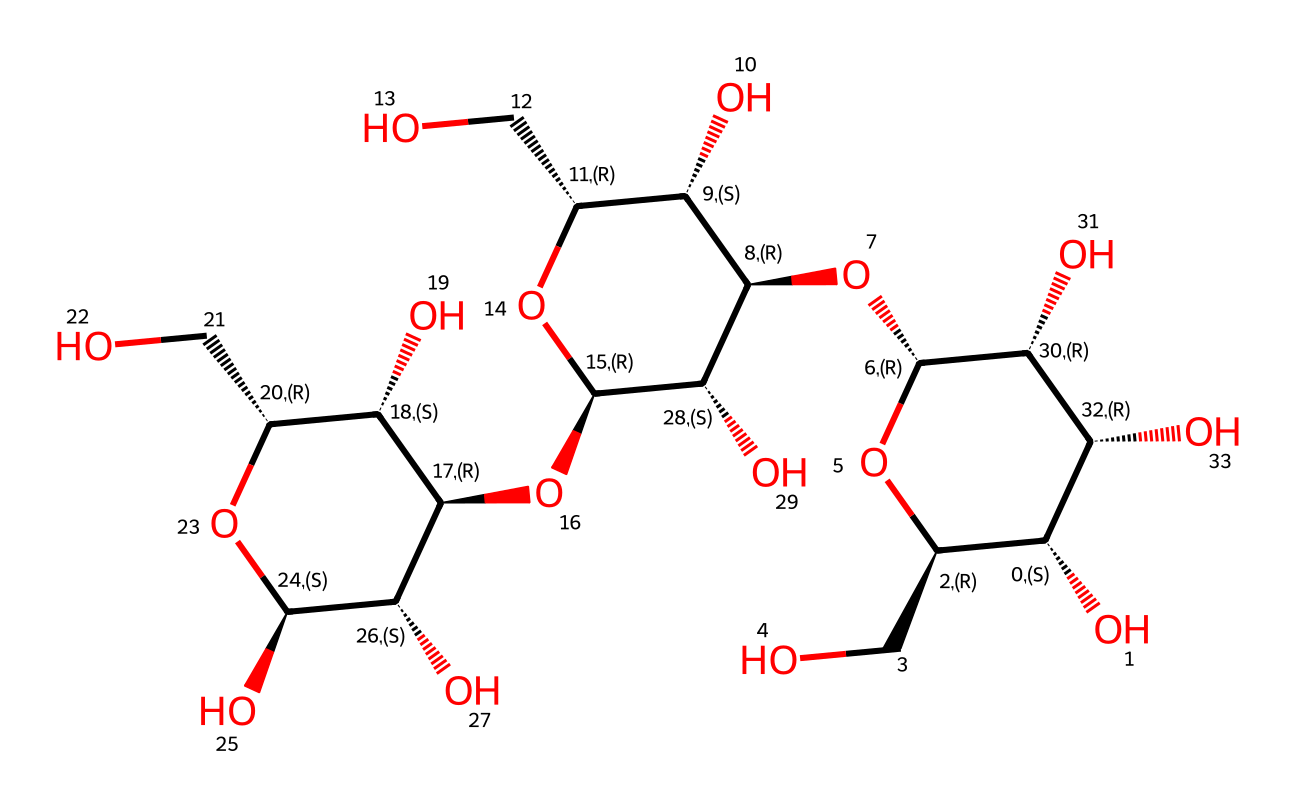What is the name of this chemical? The chemical structure corresponds to cellulose, which is a polysaccharide made up of glucose units linked by glycosidic bonds.
Answer: cellulose How many carbon atoms are present in the structure? Counting the carbon atoms in the chemical structure shows that there are 6 carbon atoms represented in each glucose unit, and with the repetitive linking, there are a total of 10 carbon atoms in the entire structure.
Answer: 10 What type of carbohydrate is represented by this structure? This structure is categorized as a polysaccharide as it is made from multiple repeating units of monosaccharides (glucose) linked together.
Answer: polysaccharide How many hydroxyl (-OH) groups are present in this molecule? By examining the structure, there are multiple -OH (hydroxyl) groups in each glucose unit and overall, there are 3 hydroxyl groups in this cellulose structure.
Answer: 3 Does this chemical have any branches in its structure? The structure displayed shows a linear arrangement of glucose units with no branching, which is characteristic of cellulose.
Answer: no What is the primary function of cellulose in food products? Cellulose primarily serves as a dietary fiber, contributing to digestive health and providing bulk to food products.
Answer: dietary fiber 